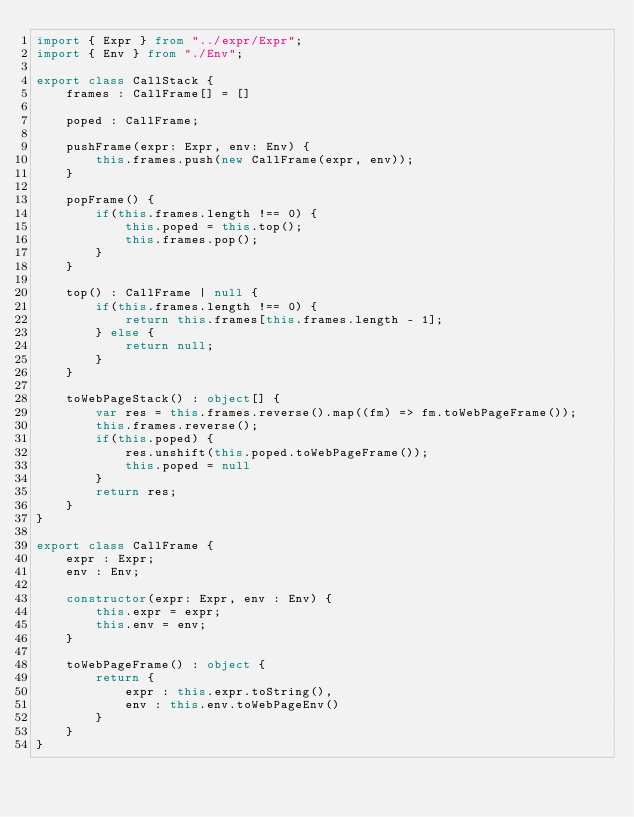<code> <loc_0><loc_0><loc_500><loc_500><_TypeScript_>import { Expr } from "../expr/Expr";
import { Env } from "./Env";

export class CallStack {
    frames : CallFrame[] = []

    poped : CallFrame;

    pushFrame(expr: Expr, env: Env) {
        this.frames.push(new CallFrame(expr, env));
    }

    popFrame() {
        if(this.frames.length !== 0) {
            this.poped = this.top();
            this.frames.pop();
        }
    }

    top() : CallFrame | null {
        if(this.frames.length !== 0) {
            return this.frames[this.frames.length - 1];
        } else {
            return null;
        }
    }

    toWebPageStack() : object[] {
        var res = this.frames.reverse().map((fm) => fm.toWebPageFrame());
        this.frames.reverse();
        if(this.poped) {
            res.unshift(this.poped.toWebPageFrame());
            this.poped = null
        }
        return res;
    }
}

export class CallFrame {
    expr : Expr;
    env : Env;

    constructor(expr: Expr, env : Env) {
        this.expr = expr;
        this.env = env;
    }

    toWebPageFrame() : object {
        return {
            expr : this.expr.toString(),
            env : this.env.toWebPageEnv()
        }
    }
}
</code> 